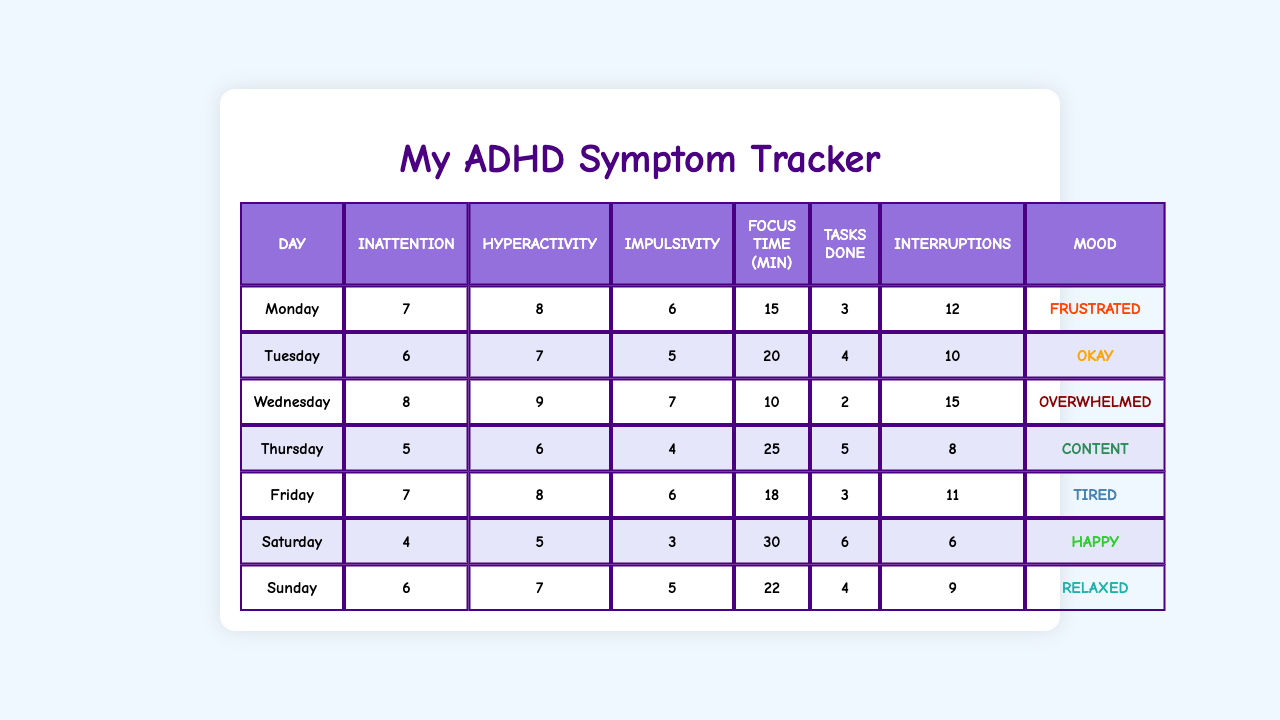What is the inattention score on Wednesday? The inattention score for Wednesday can be found directly in the table under the "Inattention" column for that day. It shows a score of 8.
Answer: 8 What mood did you have on Thursday? The mood for Thursday is listed in the table under the "Mood" column for that day, which states "Content."
Answer: Content On which day did you complete the most tasks? The number of tasks completed is present in the table. By comparing the "Tasks Done" column, Saturday has the highest value of 6 tasks completed.
Answer: Saturday What was the average focus duration for the week? To find the average focus duration, sum the "Focus Time (min)" for each day: (15 + 20 + 10 + 25 + 18 + 30 + 22) = 130. Next, divide by the number of days (7): 130 / 7 ≈ 18.57.
Answer: 18.57 Was there a day with more than 12 interruptions? Check the "Interruptions" column for each day. The data shows Wednesday had 15 interruptions, exceeding 12.
Answer: Yes Which day had the lowest hyperactivity score? The hyperactivity scores are listed in the table, and for each day, Saturday has the lowest score of 5.
Answer: Saturday What is the difference in tasks completed between Monday and Friday? Look at the "Tasks Done" column for both days. Monday completed 3 tasks and Friday completed also 3 tasks. Thus, the difference is 3 - 3 = 0.
Answer: 0 Which mood corresponds to the highest inattention score? Looking at the "Inattention" column, the highest score is 8 on Wednesday, which corresponds to the mood "Overwhelmed."
Answer: Overwhelmed On which day did you have the most interruptions relative to the tasks completed? Check both the "Interruptions" and "Tasks Done" columns. Most interruptions occurred on Wednesday with 15 interruptions and only 2 tasks completed, which shows a high ratio of interruptions to completed tasks.
Answer: Wednesday What was your mood on the day with the highest hyperactivity score? The highest hyperactivity score is 9 on Wednesday, and the corresponding mood for that day is "Overwhelmed."
Answer: Overwhelmed 